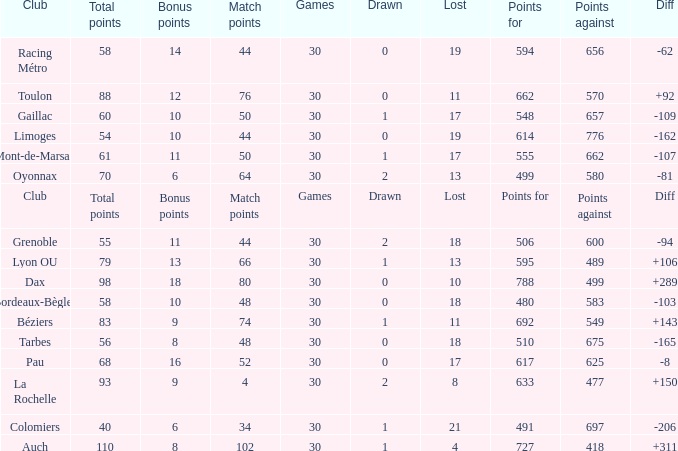What is the value of match points when the points for is 570? 76.0. 